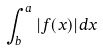<formula> <loc_0><loc_0><loc_500><loc_500>\int _ { b } ^ { a } | f ( x ) | d x</formula> 